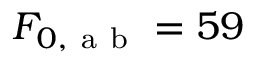Convert formula to latex. <formula><loc_0><loc_0><loc_500><loc_500>F _ { 0 , a b } = 5 9</formula> 